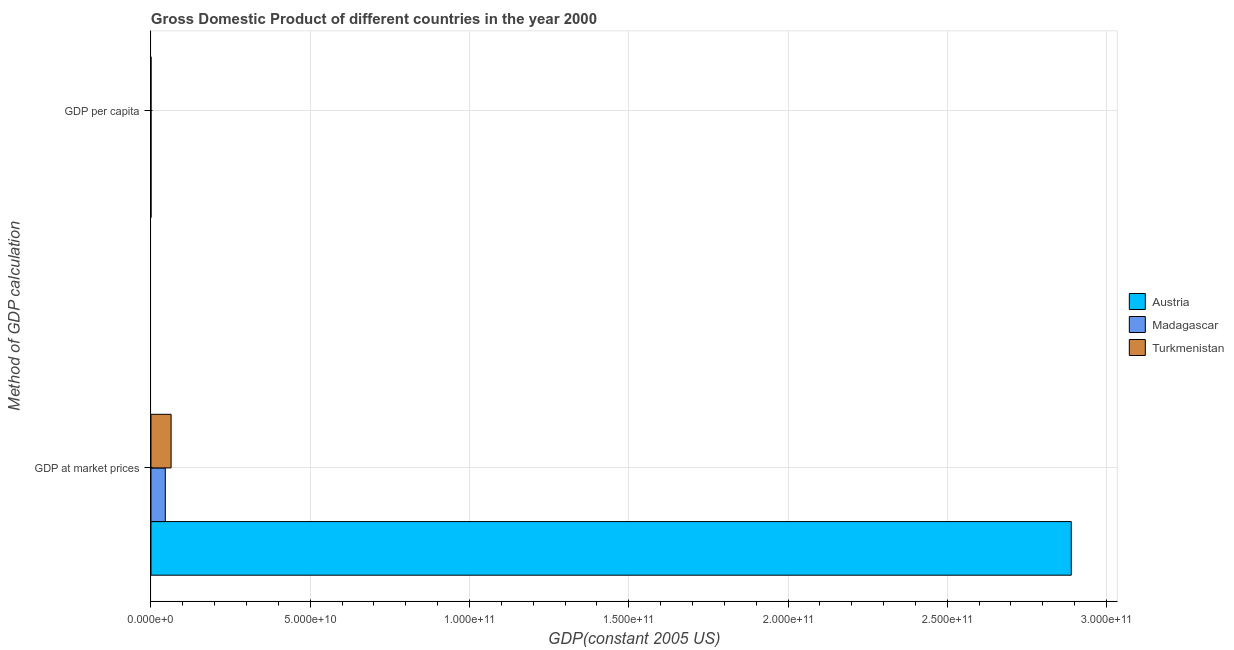Are the number of bars per tick equal to the number of legend labels?
Provide a succinct answer. Yes. What is the label of the 1st group of bars from the top?
Provide a succinct answer. GDP per capita. What is the gdp at market prices in Austria?
Ensure brevity in your answer.  2.89e+11. Across all countries, what is the maximum gdp at market prices?
Ensure brevity in your answer.  2.89e+11. Across all countries, what is the minimum gdp per capita?
Keep it short and to the point. 286. In which country was the gdp per capita maximum?
Ensure brevity in your answer.  Austria. In which country was the gdp at market prices minimum?
Provide a succinct answer. Madagascar. What is the total gdp at market prices in the graph?
Your response must be concise. 3.00e+11. What is the difference between the gdp per capita in Turkmenistan and that in Austria?
Offer a very short reply. -3.47e+04. What is the difference between the gdp per capita in Austria and the gdp at market prices in Madagascar?
Offer a very short reply. -4.50e+09. What is the average gdp at market prices per country?
Offer a terse response. 9.99e+1. What is the difference between the gdp per capita and gdp at market prices in Madagascar?
Your answer should be compact. -4.50e+09. What is the ratio of the gdp at market prices in Madagascar to that in Austria?
Offer a terse response. 0.02. What does the 3rd bar from the top in GDP at market prices represents?
Offer a terse response. Austria. What does the 2nd bar from the bottom in GDP per capita represents?
Your response must be concise. Madagascar. Are all the bars in the graph horizontal?
Your response must be concise. Yes. How many countries are there in the graph?
Offer a very short reply. 3. What is the difference between two consecutive major ticks on the X-axis?
Your response must be concise. 5.00e+1. Does the graph contain any zero values?
Provide a succinct answer. No. Where does the legend appear in the graph?
Your answer should be very brief. Center right. How many legend labels are there?
Offer a terse response. 3. How are the legend labels stacked?
Offer a terse response. Vertical. What is the title of the graph?
Provide a succinct answer. Gross Domestic Product of different countries in the year 2000. Does "Lesotho" appear as one of the legend labels in the graph?
Offer a very short reply. No. What is the label or title of the X-axis?
Your answer should be very brief. GDP(constant 2005 US). What is the label or title of the Y-axis?
Ensure brevity in your answer.  Method of GDP calculation. What is the GDP(constant 2005 US) of Austria in GDP at market prices?
Give a very brief answer. 2.89e+11. What is the GDP(constant 2005 US) of Madagascar in GDP at market prices?
Give a very brief answer. 4.50e+09. What is the GDP(constant 2005 US) of Turkmenistan in GDP at market prices?
Your answer should be very brief. 6.32e+09. What is the GDP(constant 2005 US) of Austria in GDP per capita?
Ensure brevity in your answer.  3.61e+04. What is the GDP(constant 2005 US) of Madagascar in GDP per capita?
Give a very brief answer. 286. What is the GDP(constant 2005 US) of Turkmenistan in GDP per capita?
Make the answer very short. 1404.08. Across all Method of GDP calculation, what is the maximum GDP(constant 2005 US) in Austria?
Your response must be concise. 2.89e+11. Across all Method of GDP calculation, what is the maximum GDP(constant 2005 US) in Madagascar?
Your response must be concise. 4.50e+09. Across all Method of GDP calculation, what is the maximum GDP(constant 2005 US) in Turkmenistan?
Your answer should be very brief. 6.32e+09. Across all Method of GDP calculation, what is the minimum GDP(constant 2005 US) of Austria?
Provide a short and direct response. 3.61e+04. Across all Method of GDP calculation, what is the minimum GDP(constant 2005 US) of Madagascar?
Provide a succinct answer. 286. Across all Method of GDP calculation, what is the minimum GDP(constant 2005 US) in Turkmenistan?
Offer a terse response. 1404.08. What is the total GDP(constant 2005 US) in Austria in the graph?
Ensure brevity in your answer.  2.89e+11. What is the total GDP(constant 2005 US) of Madagascar in the graph?
Your answer should be very brief. 4.50e+09. What is the total GDP(constant 2005 US) in Turkmenistan in the graph?
Offer a terse response. 6.32e+09. What is the difference between the GDP(constant 2005 US) of Austria in GDP at market prices and that in GDP per capita?
Make the answer very short. 2.89e+11. What is the difference between the GDP(constant 2005 US) of Madagascar in GDP at market prices and that in GDP per capita?
Ensure brevity in your answer.  4.50e+09. What is the difference between the GDP(constant 2005 US) of Turkmenistan in GDP at market prices and that in GDP per capita?
Give a very brief answer. 6.32e+09. What is the difference between the GDP(constant 2005 US) in Austria in GDP at market prices and the GDP(constant 2005 US) in Madagascar in GDP per capita?
Your answer should be compact. 2.89e+11. What is the difference between the GDP(constant 2005 US) of Austria in GDP at market prices and the GDP(constant 2005 US) of Turkmenistan in GDP per capita?
Give a very brief answer. 2.89e+11. What is the difference between the GDP(constant 2005 US) of Madagascar in GDP at market prices and the GDP(constant 2005 US) of Turkmenistan in GDP per capita?
Make the answer very short. 4.50e+09. What is the average GDP(constant 2005 US) in Austria per Method of GDP calculation?
Provide a succinct answer. 1.44e+11. What is the average GDP(constant 2005 US) of Madagascar per Method of GDP calculation?
Keep it short and to the point. 2.25e+09. What is the average GDP(constant 2005 US) in Turkmenistan per Method of GDP calculation?
Ensure brevity in your answer.  3.16e+09. What is the difference between the GDP(constant 2005 US) of Austria and GDP(constant 2005 US) of Madagascar in GDP at market prices?
Give a very brief answer. 2.84e+11. What is the difference between the GDP(constant 2005 US) of Austria and GDP(constant 2005 US) of Turkmenistan in GDP at market prices?
Your response must be concise. 2.83e+11. What is the difference between the GDP(constant 2005 US) in Madagascar and GDP(constant 2005 US) in Turkmenistan in GDP at market prices?
Give a very brief answer. -1.82e+09. What is the difference between the GDP(constant 2005 US) of Austria and GDP(constant 2005 US) of Madagascar in GDP per capita?
Give a very brief answer. 3.58e+04. What is the difference between the GDP(constant 2005 US) in Austria and GDP(constant 2005 US) in Turkmenistan in GDP per capita?
Offer a terse response. 3.47e+04. What is the difference between the GDP(constant 2005 US) of Madagascar and GDP(constant 2005 US) of Turkmenistan in GDP per capita?
Your answer should be very brief. -1118.08. What is the ratio of the GDP(constant 2005 US) in Austria in GDP at market prices to that in GDP per capita?
Provide a succinct answer. 8.01e+06. What is the ratio of the GDP(constant 2005 US) in Madagascar in GDP at market prices to that in GDP per capita?
Provide a succinct answer. 1.57e+07. What is the ratio of the GDP(constant 2005 US) in Turkmenistan in GDP at market prices to that in GDP per capita?
Offer a terse response. 4.50e+06. What is the difference between the highest and the second highest GDP(constant 2005 US) in Austria?
Provide a short and direct response. 2.89e+11. What is the difference between the highest and the second highest GDP(constant 2005 US) of Madagascar?
Your answer should be compact. 4.50e+09. What is the difference between the highest and the second highest GDP(constant 2005 US) in Turkmenistan?
Offer a very short reply. 6.32e+09. What is the difference between the highest and the lowest GDP(constant 2005 US) in Austria?
Keep it short and to the point. 2.89e+11. What is the difference between the highest and the lowest GDP(constant 2005 US) of Madagascar?
Ensure brevity in your answer.  4.50e+09. What is the difference between the highest and the lowest GDP(constant 2005 US) in Turkmenistan?
Give a very brief answer. 6.32e+09. 